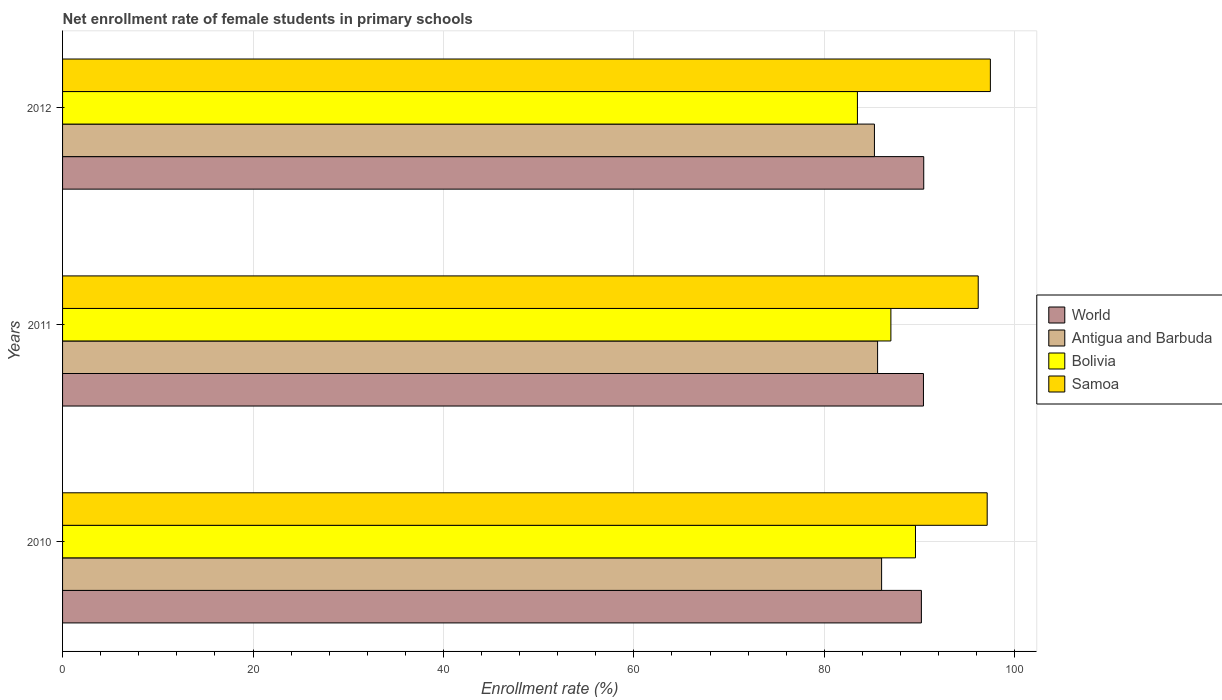How many different coloured bars are there?
Ensure brevity in your answer.  4. How many groups of bars are there?
Offer a very short reply. 3. How many bars are there on the 1st tick from the top?
Ensure brevity in your answer.  4. What is the label of the 3rd group of bars from the top?
Your response must be concise. 2010. In how many cases, is the number of bars for a given year not equal to the number of legend labels?
Ensure brevity in your answer.  0. What is the net enrollment rate of female students in primary schools in Antigua and Barbuda in 2011?
Provide a succinct answer. 85.59. Across all years, what is the maximum net enrollment rate of female students in primary schools in World?
Your response must be concise. 90.44. Across all years, what is the minimum net enrollment rate of female students in primary schools in Antigua and Barbuda?
Your answer should be very brief. 85.26. In which year was the net enrollment rate of female students in primary schools in Bolivia minimum?
Ensure brevity in your answer.  2012. What is the total net enrollment rate of female students in primary schools in Antigua and Barbuda in the graph?
Your answer should be very brief. 256.87. What is the difference between the net enrollment rate of female students in primary schools in Antigua and Barbuda in 2011 and that in 2012?
Your answer should be compact. 0.33. What is the difference between the net enrollment rate of female students in primary schools in Bolivia in 2010 and the net enrollment rate of female students in primary schools in Antigua and Barbuda in 2011?
Your response must be concise. 3.98. What is the average net enrollment rate of female students in primary schools in Antigua and Barbuda per year?
Keep it short and to the point. 85.62. In the year 2011, what is the difference between the net enrollment rate of female students in primary schools in Samoa and net enrollment rate of female students in primary schools in Bolivia?
Provide a succinct answer. 9.17. What is the ratio of the net enrollment rate of female students in primary schools in World in 2011 to that in 2012?
Provide a succinct answer. 1. Is the difference between the net enrollment rate of female students in primary schools in Samoa in 2010 and 2011 greater than the difference between the net enrollment rate of female students in primary schools in Bolivia in 2010 and 2011?
Your answer should be compact. No. What is the difference between the highest and the second highest net enrollment rate of female students in primary schools in Samoa?
Offer a terse response. 0.34. What is the difference between the highest and the lowest net enrollment rate of female students in primary schools in Bolivia?
Offer a terse response. 6.1. In how many years, is the net enrollment rate of female students in primary schools in Bolivia greater than the average net enrollment rate of female students in primary schools in Bolivia taken over all years?
Give a very brief answer. 2. What does the 1st bar from the top in 2011 represents?
Ensure brevity in your answer.  Samoa. What does the 2nd bar from the bottom in 2010 represents?
Your response must be concise. Antigua and Barbuda. Is it the case that in every year, the sum of the net enrollment rate of female students in primary schools in Samoa and net enrollment rate of female students in primary schools in World is greater than the net enrollment rate of female students in primary schools in Bolivia?
Offer a terse response. Yes. How many years are there in the graph?
Offer a terse response. 3. Are the values on the major ticks of X-axis written in scientific E-notation?
Give a very brief answer. No. Does the graph contain grids?
Give a very brief answer. Yes. How many legend labels are there?
Make the answer very short. 4. What is the title of the graph?
Provide a short and direct response. Net enrollment rate of female students in primary schools. What is the label or title of the X-axis?
Offer a very short reply. Enrollment rate (%). What is the Enrollment rate (%) in World in 2010?
Your response must be concise. 90.19. What is the Enrollment rate (%) of Antigua and Barbuda in 2010?
Keep it short and to the point. 86.01. What is the Enrollment rate (%) of Bolivia in 2010?
Provide a short and direct response. 89.57. What is the Enrollment rate (%) of Samoa in 2010?
Your answer should be compact. 97.1. What is the Enrollment rate (%) of World in 2011?
Provide a short and direct response. 90.41. What is the Enrollment rate (%) of Antigua and Barbuda in 2011?
Your response must be concise. 85.59. What is the Enrollment rate (%) of Bolivia in 2011?
Make the answer very short. 86.99. What is the Enrollment rate (%) in Samoa in 2011?
Offer a terse response. 96.16. What is the Enrollment rate (%) in World in 2012?
Give a very brief answer. 90.44. What is the Enrollment rate (%) in Antigua and Barbuda in 2012?
Your answer should be very brief. 85.26. What is the Enrollment rate (%) in Bolivia in 2012?
Provide a short and direct response. 83.47. What is the Enrollment rate (%) in Samoa in 2012?
Make the answer very short. 97.44. Across all years, what is the maximum Enrollment rate (%) of World?
Keep it short and to the point. 90.44. Across all years, what is the maximum Enrollment rate (%) of Antigua and Barbuda?
Provide a succinct answer. 86.01. Across all years, what is the maximum Enrollment rate (%) of Bolivia?
Provide a short and direct response. 89.57. Across all years, what is the maximum Enrollment rate (%) in Samoa?
Give a very brief answer. 97.44. Across all years, what is the minimum Enrollment rate (%) of World?
Offer a very short reply. 90.19. Across all years, what is the minimum Enrollment rate (%) of Antigua and Barbuda?
Keep it short and to the point. 85.26. Across all years, what is the minimum Enrollment rate (%) of Bolivia?
Ensure brevity in your answer.  83.47. Across all years, what is the minimum Enrollment rate (%) of Samoa?
Offer a very short reply. 96.16. What is the total Enrollment rate (%) in World in the graph?
Your response must be concise. 271.04. What is the total Enrollment rate (%) in Antigua and Barbuda in the graph?
Provide a short and direct response. 256.87. What is the total Enrollment rate (%) of Bolivia in the graph?
Keep it short and to the point. 260.04. What is the total Enrollment rate (%) of Samoa in the graph?
Your answer should be very brief. 290.7. What is the difference between the Enrollment rate (%) in World in 2010 and that in 2011?
Your response must be concise. -0.22. What is the difference between the Enrollment rate (%) in Antigua and Barbuda in 2010 and that in 2011?
Ensure brevity in your answer.  0.42. What is the difference between the Enrollment rate (%) of Bolivia in 2010 and that in 2011?
Offer a terse response. 2.58. What is the difference between the Enrollment rate (%) of Samoa in 2010 and that in 2011?
Provide a short and direct response. 0.94. What is the difference between the Enrollment rate (%) in World in 2010 and that in 2012?
Provide a succinct answer. -0.25. What is the difference between the Enrollment rate (%) of Antigua and Barbuda in 2010 and that in 2012?
Ensure brevity in your answer.  0.75. What is the difference between the Enrollment rate (%) in Bolivia in 2010 and that in 2012?
Offer a terse response. 6.1. What is the difference between the Enrollment rate (%) in Samoa in 2010 and that in 2012?
Your response must be concise. -0.34. What is the difference between the Enrollment rate (%) of World in 2011 and that in 2012?
Your response must be concise. -0.03. What is the difference between the Enrollment rate (%) in Antigua and Barbuda in 2011 and that in 2012?
Keep it short and to the point. 0.33. What is the difference between the Enrollment rate (%) in Bolivia in 2011 and that in 2012?
Offer a terse response. 3.51. What is the difference between the Enrollment rate (%) in Samoa in 2011 and that in 2012?
Ensure brevity in your answer.  -1.28. What is the difference between the Enrollment rate (%) in World in 2010 and the Enrollment rate (%) in Antigua and Barbuda in 2011?
Your answer should be very brief. 4.6. What is the difference between the Enrollment rate (%) in World in 2010 and the Enrollment rate (%) in Bolivia in 2011?
Provide a short and direct response. 3.2. What is the difference between the Enrollment rate (%) in World in 2010 and the Enrollment rate (%) in Samoa in 2011?
Provide a short and direct response. -5.97. What is the difference between the Enrollment rate (%) of Antigua and Barbuda in 2010 and the Enrollment rate (%) of Bolivia in 2011?
Provide a succinct answer. -0.98. What is the difference between the Enrollment rate (%) of Antigua and Barbuda in 2010 and the Enrollment rate (%) of Samoa in 2011?
Your answer should be very brief. -10.15. What is the difference between the Enrollment rate (%) in Bolivia in 2010 and the Enrollment rate (%) in Samoa in 2011?
Make the answer very short. -6.59. What is the difference between the Enrollment rate (%) in World in 2010 and the Enrollment rate (%) in Antigua and Barbuda in 2012?
Provide a succinct answer. 4.93. What is the difference between the Enrollment rate (%) of World in 2010 and the Enrollment rate (%) of Bolivia in 2012?
Your response must be concise. 6.72. What is the difference between the Enrollment rate (%) of World in 2010 and the Enrollment rate (%) of Samoa in 2012?
Make the answer very short. -7.25. What is the difference between the Enrollment rate (%) of Antigua and Barbuda in 2010 and the Enrollment rate (%) of Bolivia in 2012?
Keep it short and to the point. 2.54. What is the difference between the Enrollment rate (%) of Antigua and Barbuda in 2010 and the Enrollment rate (%) of Samoa in 2012?
Your response must be concise. -11.42. What is the difference between the Enrollment rate (%) in Bolivia in 2010 and the Enrollment rate (%) in Samoa in 2012?
Your answer should be very brief. -7.87. What is the difference between the Enrollment rate (%) of World in 2011 and the Enrollment rate (%) of Antigua and Barbuda in 2012?
Keep it short and to the point. 5.15. What is the difference between the Enrollment rate (%) of World in 2011 and the Enrollment rate (%) of Bolivia in 2012?
Ensure brevity in your answer.  6.93. What is the difference between the Enrollment rate (%) in World in 2011 and the Enrollment rate (%) in Samoa in 2012?
Keep it short and to the point. -7.03. What is the difference between the Enrollment rate (%) in Antigua and Barbuda in 2011 and the Enrollment rate (%) in Bolivia in 2012?
Your response must be concise. 2.12. What is the difference between the Enrollment rate (%) of Antigua and Barbuda in 2011 and the Enrollment rate (%) of Samoa in 2012?
Keep it short and to the point. -11.85. What is the difference between the Enrollment rate (%) in Bolivia in 2011 and the Enrollment rate (%) in Samoa in 2012?
Make the answer very short. -10.45. What is the average Enrollment rate (%) of World per year?
Give a very brief answer. 90.35. What is the average Enrollment rate (%) of Antigua and Barbuda per year?
Give a very brief answer. 85.62. What is the average Enrollment rate (%) in Bolivia per year?
Your response must be concise. 86.68. What is the average Enrollment rate (%) in Samoa per year?
Your answer should be compact. 96.9. In the year 2010, what is the difference between the Enrollment rate (%) of World and Enrollment rate (%) of Antigua and Barbuda?
Your answer should be very brief. 4.18. In the year 2010, what is the difference between the Enrollment rate (%) in World and Enrollment rate (%) in Bolivia?
Keep it short and to the point. 0.62. In the year 2010, what is the difference between the Enrollment rate (%) of World and Enrollment rate (%) of Samoa?
Keep it short and to the point. -6.91. In the year 2010, what is the difference between the Enrollment rate (%) in Antigua and Barbuda and Enrollment rate (%) in Bolivia?
Ensure brevity in your answer.  -3.56. In the year 2010, what is the difference between the Enrollment rate (%) of Antigua and Barbuda and Enrollment rate (%) of Samoa?
Offer a very short reply. -11.09. In the year 2010, what is the difference between the Enrollment rate (%) of Bolivia and Enrollment rate (%) of Samoa?
Offer a very short reply. -7.53. In the year 2011, what is the difference between the Enrollment rate (%) of World and Enrollment rate (%) of Antigua and Barbuda?
Keep it short and to the point. 4.82. In the year 2011, what is the difference between the Enrollment rate (%) in World and Enrollment rate (%) in Bolivia?
Your answer should be very brief. 3.42. In the year 2011, what is the difference between the Enrollment rate (%) of World and Enrollment rate (%) of Samoa?
Give a very brief answer. -5.75. In the year 2011, what is the difference between the Enrollment rate (%) of Antigua and Barbuda and Enrollment rate (%) of Bolivia?
Your response must be concise. -1.4. In the year 2011, what is the difference between the Enrollment rate (%) of Antigua and Barbuda and Enrollment rate (%) of Samoa?
Provide a succinct answer. -10.57. In the year 2011, what is the difference between the Enrollment rate (%) of Bolivia and Enrollment rate (%) of Samoa?
Ensure brevity in your answer.  -9.17. In the year 2012, what is the difference between the Enrollment rate (%) in World and Enrollment rate (%) in Antigua and Barbuda?
Give a very brief answer. 5.18. In the year 2012, what is the difference between the Enrollment rate (%) in World and Enrollment rate (%) in Bolivia?
Provide a succinct answer. 6.96. In the year 2012, what is the difference between the Enrollment rate (%) of World and Enrollment rate (%) of Samoa?
Your answer should be very brief. -7. In the year 2012, what is the difference between the Enrollment rate (%) of Antigua and Barbuda and Enrollment rate (%) of Bolivia?
Offer a terse response. 1.79. In the year 2012, what is the difference between the Enrollment rate (%) in Antigua and Barbuda and Enrollment rate (%) in Samoa?
Ensure brevity in your answer.  -12.18. In the year 2012, what is the difference between the Enrollment rate (%) in Bolivia and Enrollment rate (%) in Samoa?
Provide a succinct answer. -13.96. What is the ratio of the Enrollment rate (%) of World in 2010 to that in 2011?
Your response must be concise. 1. What is the ratio of the Enrollment rate (%) in Antigua and Barbuda in 2010 to that in 2011?
Your answer should be very brief. 1. What is the ratio of the Enrollment rate (%) in Bolivia in 2010 to that in 2011?
Provide a succinct answer. 1.03. What is the ratio of the Enrollment rate (%) in Samoa in 2010 to that in 2011?
Keep it short and to the point. 1.01. What is the ratio of the Enrollment rate (%) in Antigua and Barbuda in 2010 to that in 2012?
Offer a very short reply. 1.01. What is the ratio of the Enrollment rate (%) in Bolivia in 2010 to that in 2012?
Offer a very short reply. 1.07. What is the ratio of the Enrollment rate (%) of World in 2011 to that in 2012?
Provide a short and direct response. 1. What is the ratio of the Enrollment rate (%) in Antigua and Barbuda in 2011 to that in 2012?
Your answer should be very brief. 1. What is the ratio of the Enrollment rate (%) of Bolivia in 2011 to that in 2012?
Keep it short and to the point. 1.04. What is the ratio of the Enrollment rate (%) in Samoa in 2011 to that in 2012?
Provide a short and direct response. 0.99. What is the difference between the highest and the second highest Enrollment rate (%) of World?
Your response must be concise. 0.03. What is the difference between the highest and the second highest Enrollment rate (%) in Antigua and Barbuda?
Give a very brief answer. 0.42. What is the difference between the highest and the second highest Enrollment rate (%) of Bolivia?
Your answer should be compact. 2.58. What is the difference between the highest and the second highest Enrollment rate (%) of Samoa?
Offer a very short reply. 0.34. What is the difference between the highest and the lowest Enrollment rate (%) in World?
Give a very brief answer. 0.25. What is the difference between the highest and the lowest Enrollment rate (%) in Antigua and Barbuda?
Your answer should be very brief. 0.75. What is the difference between the highest and the lowest Enrollment rate (%) of Bolivia?
Give a very brief answer. 6.1. What is the difference between the highest and the lowest Enrollment rate (%) of Samoa?
Offer a very short reply. 1.28. 